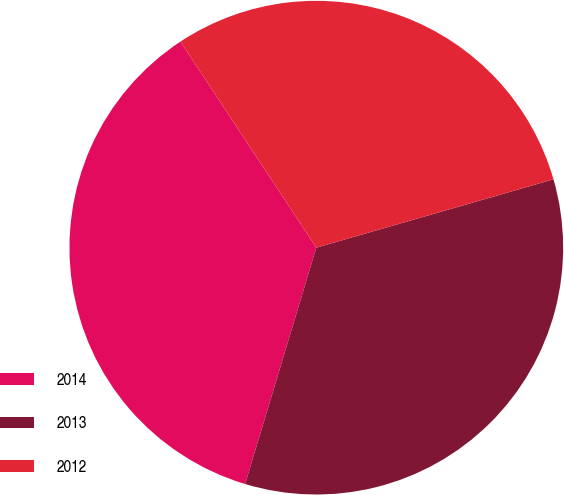<chart> <loc_0><loc_0><loc_500><loc_500><pie_chart><fcel>2014<fcel>2013<fcel>2012<nl><fcel>36.07%<fcel>34.12%<fcel>29.81%<nl></chart> 